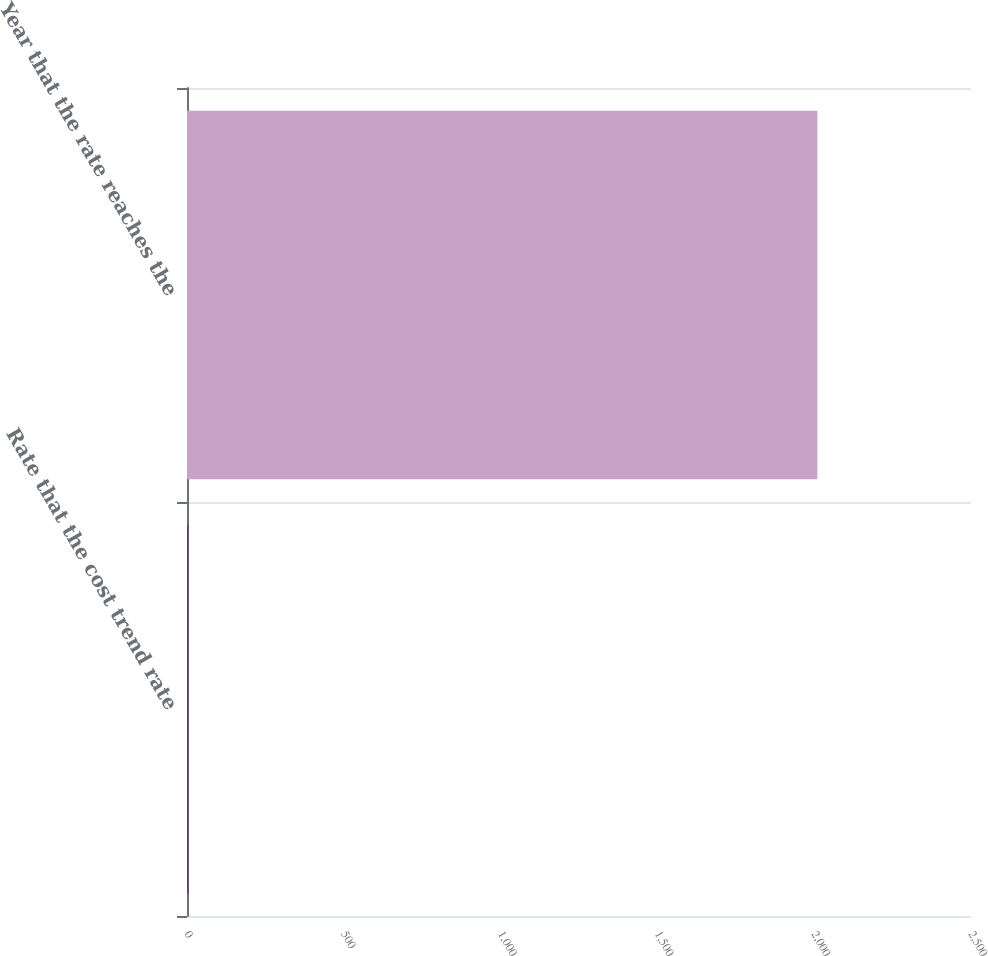Convert chart to OTSL. <chart><loc_0><loc_0><loc_500><loc_500><bar_chart><fcel>Rate that the cost trend rate<fcel>Year that the rate reaches the<nl><fcel>5<fcel>2010<nl></chart> 